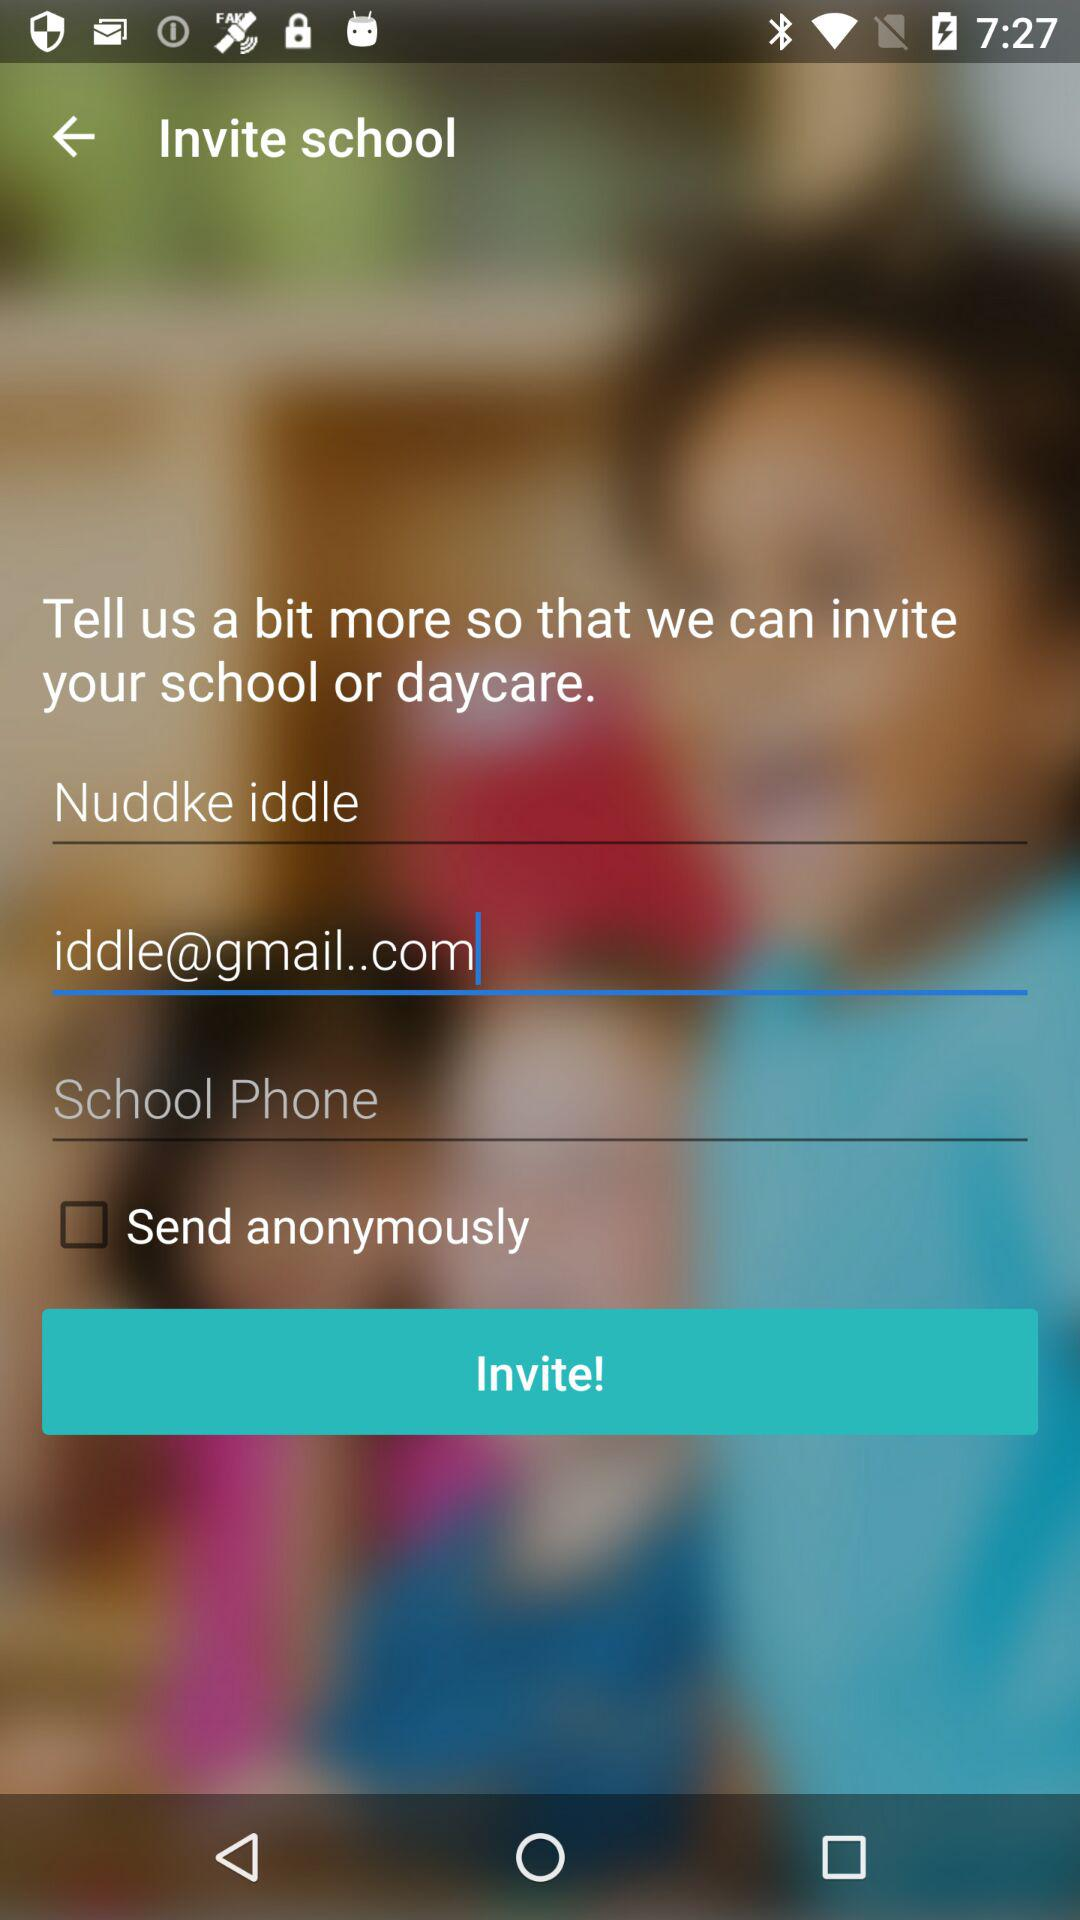How many fields are there for the user to enter information about their school?
Answer the question using a single word or phrase. 3 